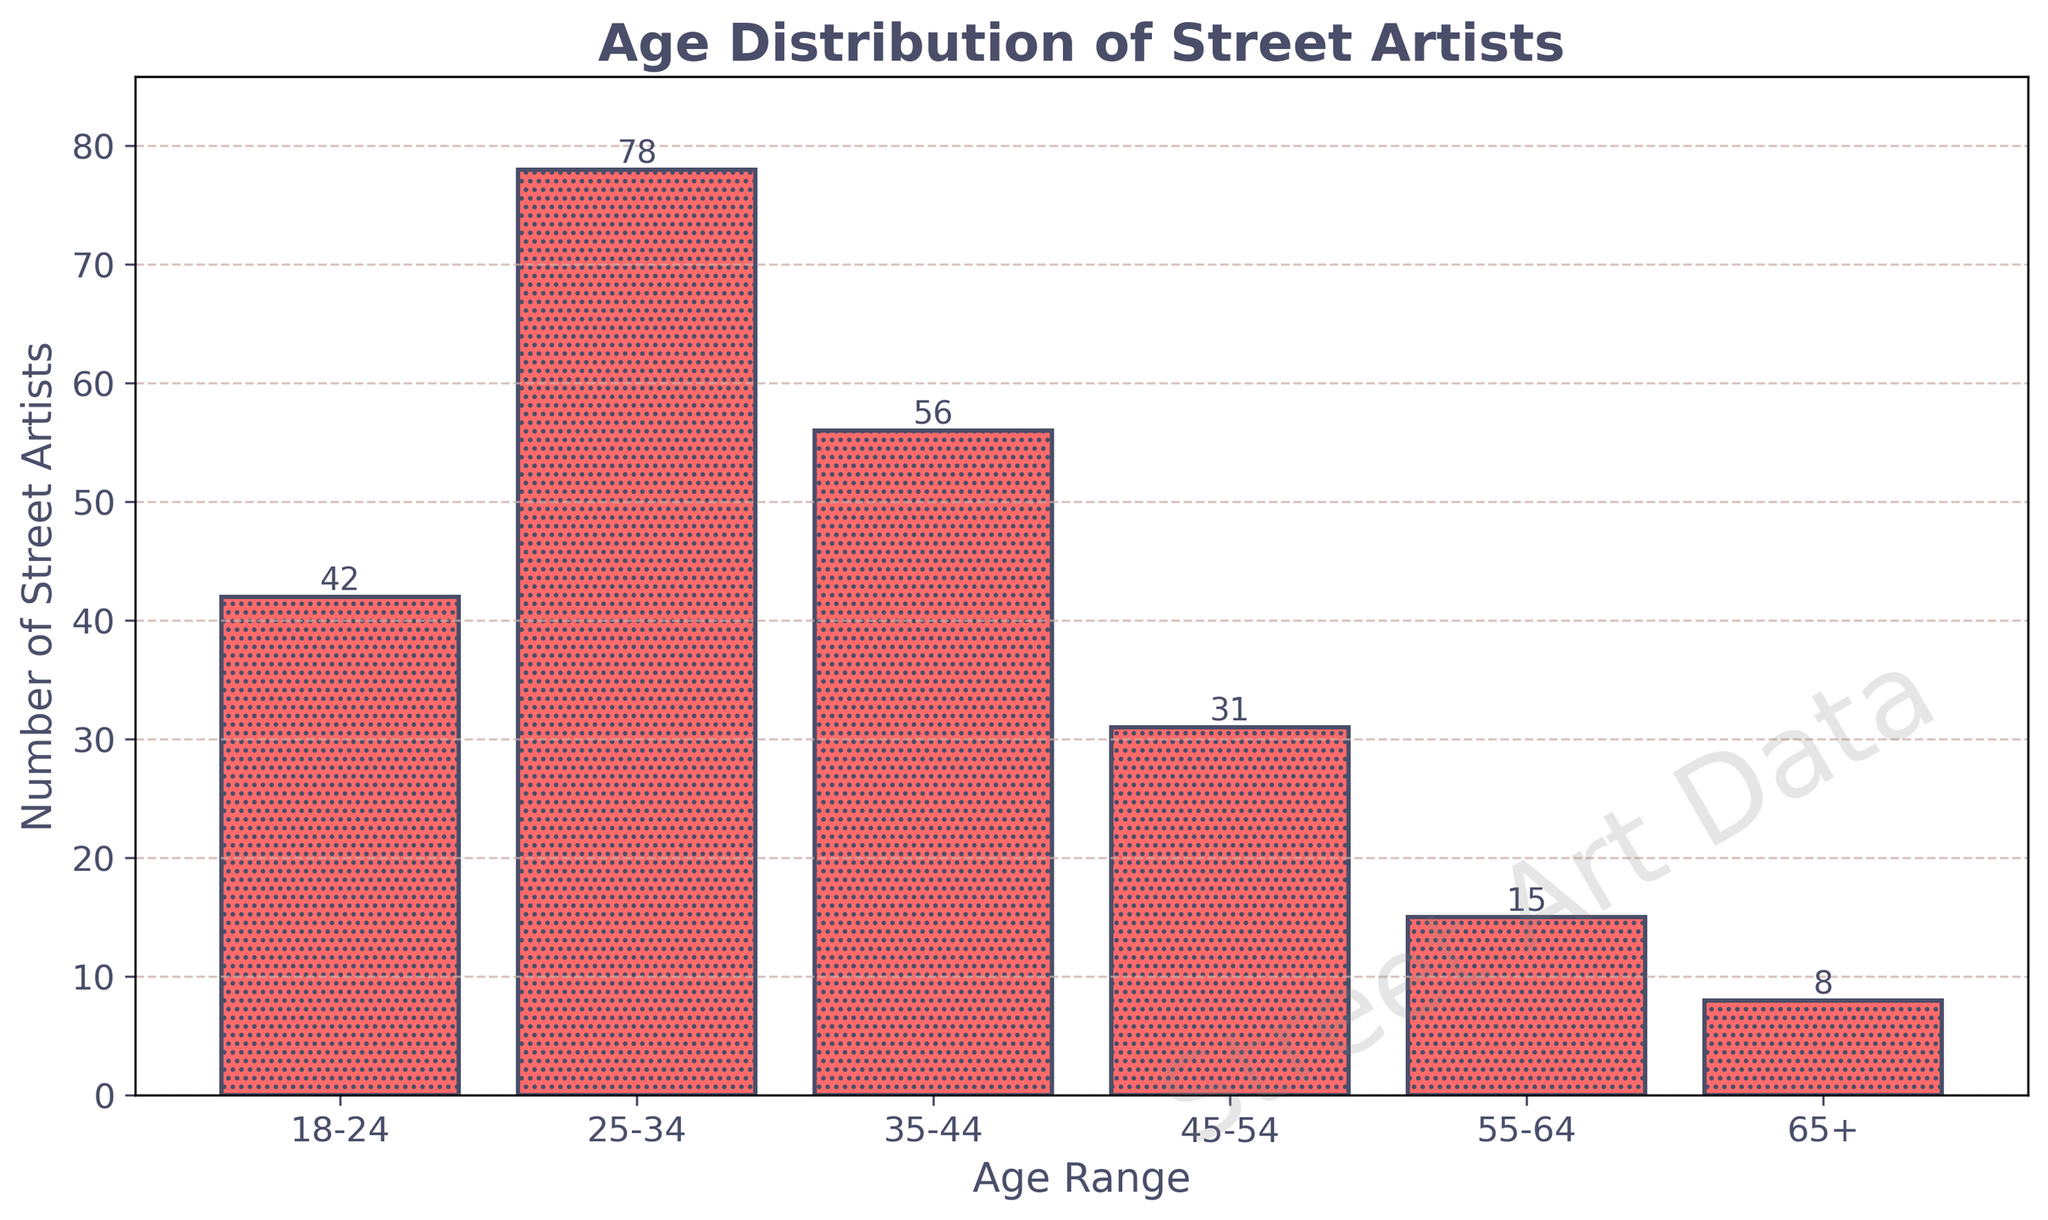What is the title of the histogram? The title can be found at the top of the histogram. It reads: "Age Distribution of Street Artists."
Answer: Age Distribution of Street Artists How many age ranges are represented in the histogram? Count the distinct age ranges listed on the x-axis of the histogram. They are: 18-24, 25-34, 35-44, 45-54, 55-64, and 65+.
Answer: 6 Which age range has the highest number of street artists? Look for the tallest bar in the histogram. The tallest bar corresponds to the age range of 25-34.
Answer: 25-34 What is the number of street artists in the 45-54 age range? Find the bar corresponding to the 45-54 age range and read the number on top of the bar.
Answer: 31 How does the number of street artists aged 18-24 compare to those aged 65+? Compare the heights of the two bars corresponding to the age ranges 18-24 and 65+. The bar for 18-24 is much higher than the bar for 65+.
Answer: The 18-24 age range has more street artists What is the total number of street artists across all age ranges? Sum the number of street artists in each age range: 42 (18-24) + 78 (25-34) + 56 (35-44) + 31 (45-54) + 15 (55-64) + 8 (65+).
Answer: 230 How many more street artists are there in the 25-34 age range compared to the 55-64 age range? Subtract the number of artists in the 55-64 age range (15) from the number in the 25-34 age range (78).
Answer: 63 What is the average number of street artists per age range? Divide the total number of street artists (230) by the number of age ranges (6).
Answer: 38.33 Which age range has the closest number of street artists to the mean value? Calculate the mean (230/6 = 38.33) and find the age range whose artists' count is closest to this value. This is 18-24 with 42 street artists.
Answer: 18-24 What unique visual element is added to the bars in this histogram? Look closely at the bars in the histogram. They have a '....' pattern hatch as well as a border color. Additionally, a spray paint effect is applied.
Answer: '....' pattern and spray paint effect 